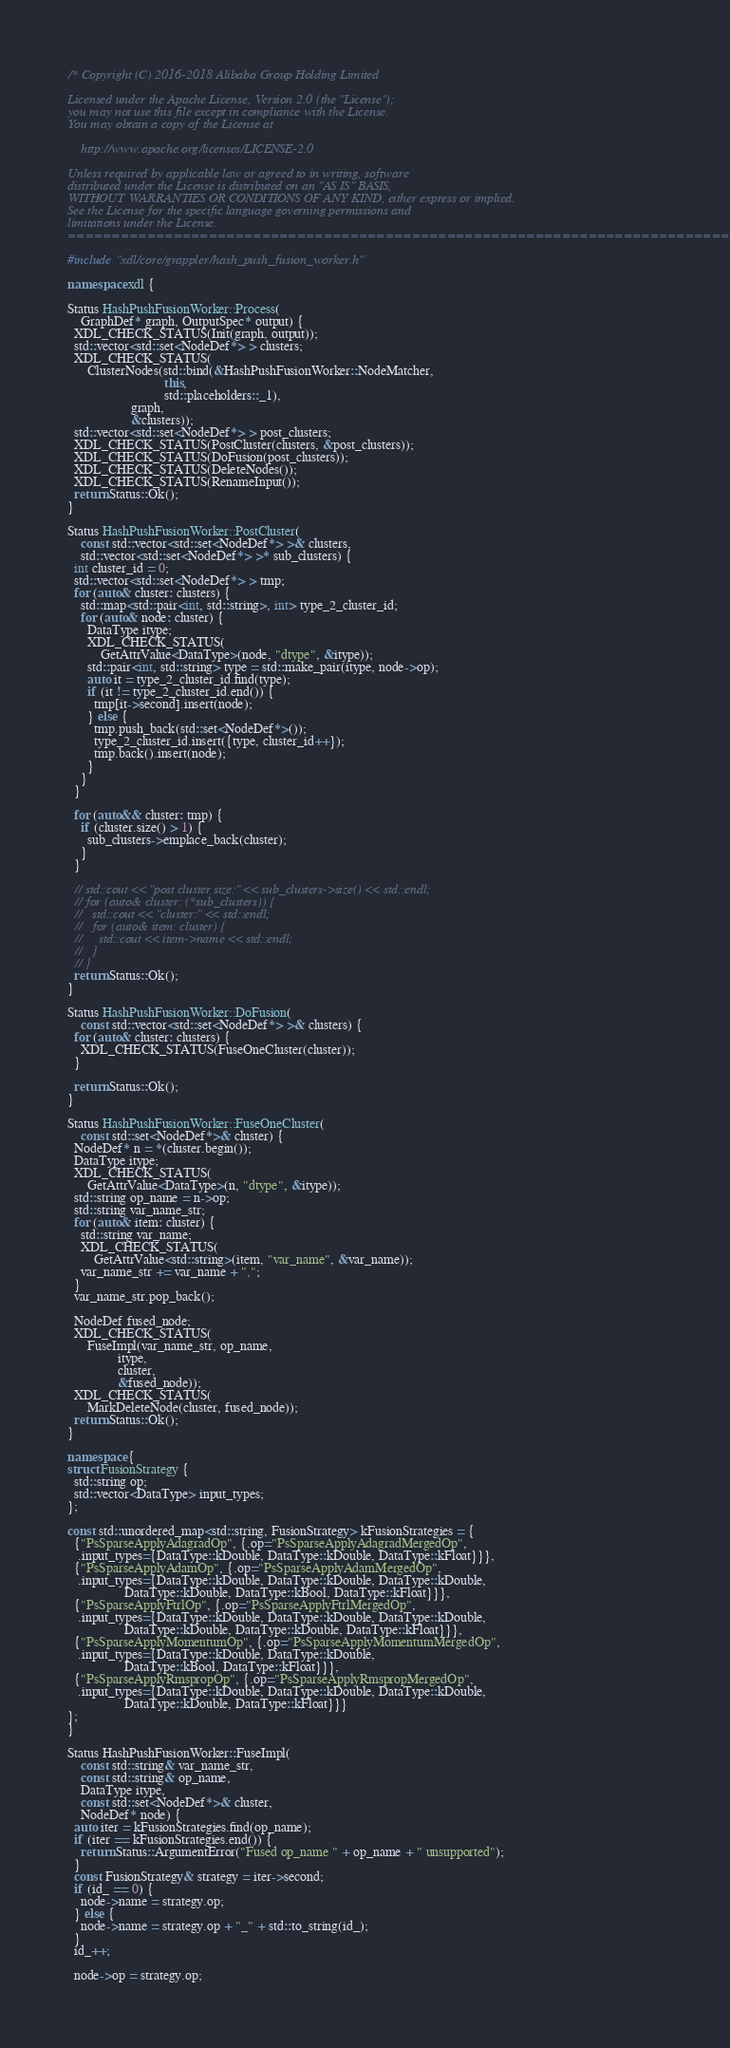<code> <loc_0><loc_0><loc_500><loc_500><_C++_>/* Copyright (C) 2016-2018 Alibaba Group Holding Limited

Licensed under the Apache License, Version 2.0 (the "License");
you may not use this file except in compliance with the License.
You may obtain a copy of the License at

    http://www.apache.org/licenses/LICENSE-2.0

Unless required by applicable law or agreed to in writing, software
distributed under the License is distributed on an "AS IS" BASIS,
WITHOUT WARRANTIES OR CONDITIONS OF ANY KIND, either express or implied.
See the License for the specific language governing permissions and
limitations under the License.
==============================================================================*/

#include "xdl/core/grappler/hash_push_fusion_worker.h"

namespace xdl {

Status HashPushFusionWorker::Process(
    GraphDef* graph, OutputSpec* output) {
  XDL_CHECK_STATUS(Init(graph, output));
  std::vector<std::set<NodeDef*> > clusters;
  XDL_CHECK_STATUS(
      ClusterNodes(std::bind(&HashPushFusionWorker::NodeMatcher, 
                             this, 
                             std::placeholders::_1),
                   graph, 
                   &clusters));
  std::vector<std::set<NodeDef*> > post_clusters;
  XDL_CHECK_STATUS(PostCluster(clusters, &post_clusters));
  XDL_CHECK_STATUS(DoFusion(post_clusters));
  XDL_CHECK_STATUS(DeleteNodes());
  XDL_CHECK_STATUS(RenameInput());
  return Status::Ok();
}

Status HashPushFusionWorker::PostCluster(
    const std::vector<std::set<NodeDef*> >& clusters,
    std::vector<std::set<NodeDef*> >* sub_clusters) {
  int cluster_id = 0;
  std::vector<std::set<NodeDef*> > tmp;
  for (auto& cluster: clusters) {
    std::map<std::pair<int, std::string>, int> type_2_cluster_id;
    for (auto& node: cluster) {
      DataType itype;
      XDL_CHECK_STATUS(
          GetAttrValue<DataType>(node, "dtype", &itype)); 
      std::pair<int, std::string> type = std::make_pair(itype, node->op);
      auto it = type_2_cluster_id.find(type);
      if (it != type_2_cluster_id.end()) {
        tmp[it->second].insert(node);
      } else {
        tmp.push_back(std::set<NodeDef*>());
        type_2_cluster_id.insert({type, cluster_id++});
        tmp.back().insert(node);
      }
    }
  }

  for (auto&& cluster: tmp) {
    if (cluster.size() > 1) { 
      sub_clusters->emplace_back(cluster);
    }
  }

  // std::cout << "post cluster size:" << sub_clusters->size() << std::endl;
  // for (auto& cluster: (*sub_clusters)) {
  //   std::cout << "cluster:" << std::endl;
  //   for (auto& item: cluster) {
  //     std::cout << item->name << std::endl;
  //   }
  // }
  return Status::Ok();
}

Status HashPushFusionWorker::DoFusion(
    const std::vector<std::set<NodeDef*> >& clusters) {
  for (auto& cluster: clusters) {
    XDL_CHECK_STATUS(FuseOneCluster(cluster));
  }

  return Status::Ok();
}

Status HashPushFusionWorker::FuseOneCluster(
    const std::set<NodeDef*>& cluster) {
  NodeDef* n = *(cluster.begin());
  DataType itype;
  XDL_CHECK_STATUS(
      GetAttrValue<DataType>(n, "dtype", &itype));   
  std::string op_name = n->op;
  std::string var_name_str;
  for (auto& item: cluster) {
    std::string var_name;
    XDL_CHECK_STATUS(
        GetAttrValue<std::string>(item, "var_name", &var_name));    
    var_name_str += var_name + ",";
  }
  var_name_str.pop_back();

  NodeDef fused_node;
  XDL_CHECK_STATUS(
      FuseImpl(var_name_str, op_name,
               itype,
               cluster,
               &fused_node));
  XDL_CHECK_STATUS(
      MarkDeleteNode(cluster, fused_node));
  return Status::Ok();
}

namespace {
struct FusionStrategy {
  std::string op;
  std::vector<DataType> input_types;
};

const std::unordered_map<std::string, FusionStrategy> kFusionStrategies = {
  {"PsSparseApplyAdagradOp", {.op="PsSparseApplyAdagradMergedOp",
   .input_types={DataType::kDouble, DataType::kDouble, DataType::kFloat}}},
  {"PsSparseApplyAdamOp", {.op="PsSparseApplyAdamMergedOp",
   .input_types={DataType::kDouble, DataType::kDouble, DataType::kDouble,
                 DataType::kDouble, DataType::kBool, DataType::kFloat}}},
  {"PsSparseApplyFtrlOp", {.op="PsSparseApplyFtrlMergedOp",
   .input_types={DataType::kDouble, DataType::kDouble, DataType::kDouble,
                 DataType::kDouble, DataType::kDouble, DataType::kFloat}}},
  {"PsSparseApplyMomentumOp", {.op="PsSparseApplyMomentumMergedOp",
   .input_types={DataType::kDouble, DataType::kDouble,
                 DataType::kBool, DataType::kFloat}}},
  {"PsSparseApplyRmspropOp", {.op="PsSparseApplyRmspropMergedOp",
   .input_types={DataType::kDouble, DataType::kDouble, DataType::kDouble,
                 DataType::kDouble, DataType::kFloat}}}
};
}

Status HashPushFusionWorker::FuseImpl(
    const std::string& var_name_str,
    const std::string& op_name,
    DataType itype,
    const std::set<NodeDef*>& cluster,
    NodeDef* node) {
  auto iter = kFusionStrategies.find(op_name);
  if (iter == kFusionStrategies.end()) {
    return Status::ArgumentError("Fused op_name " + op_name + " unsupported");
  }
  const FusionStrategy& strategy = iter->second;
  if (id_ == 0) {
    node->name = strategy.op;
  } else {
    node->name = strategy.op + "_" + std::to_string(id_);
  }
  id_++;

  node->op = strategy.op;
</code> 